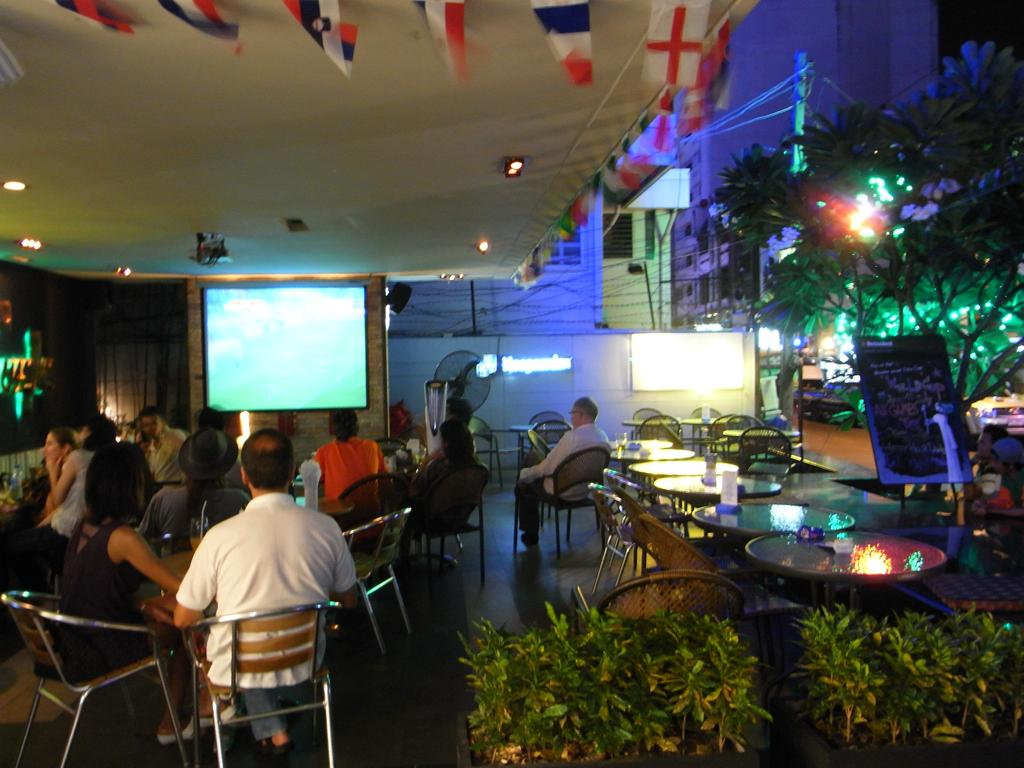What are the people in the image doing? The people are sitting on chairs at a table and looking at a screen. What can be seen in the background of the image? There are trees, plants, lights, poles, and buildings on the right side of the image. What scientific discoveries are the people discussing in the image? There is no indication in the image that the people are discussing any scientific discoveries. 